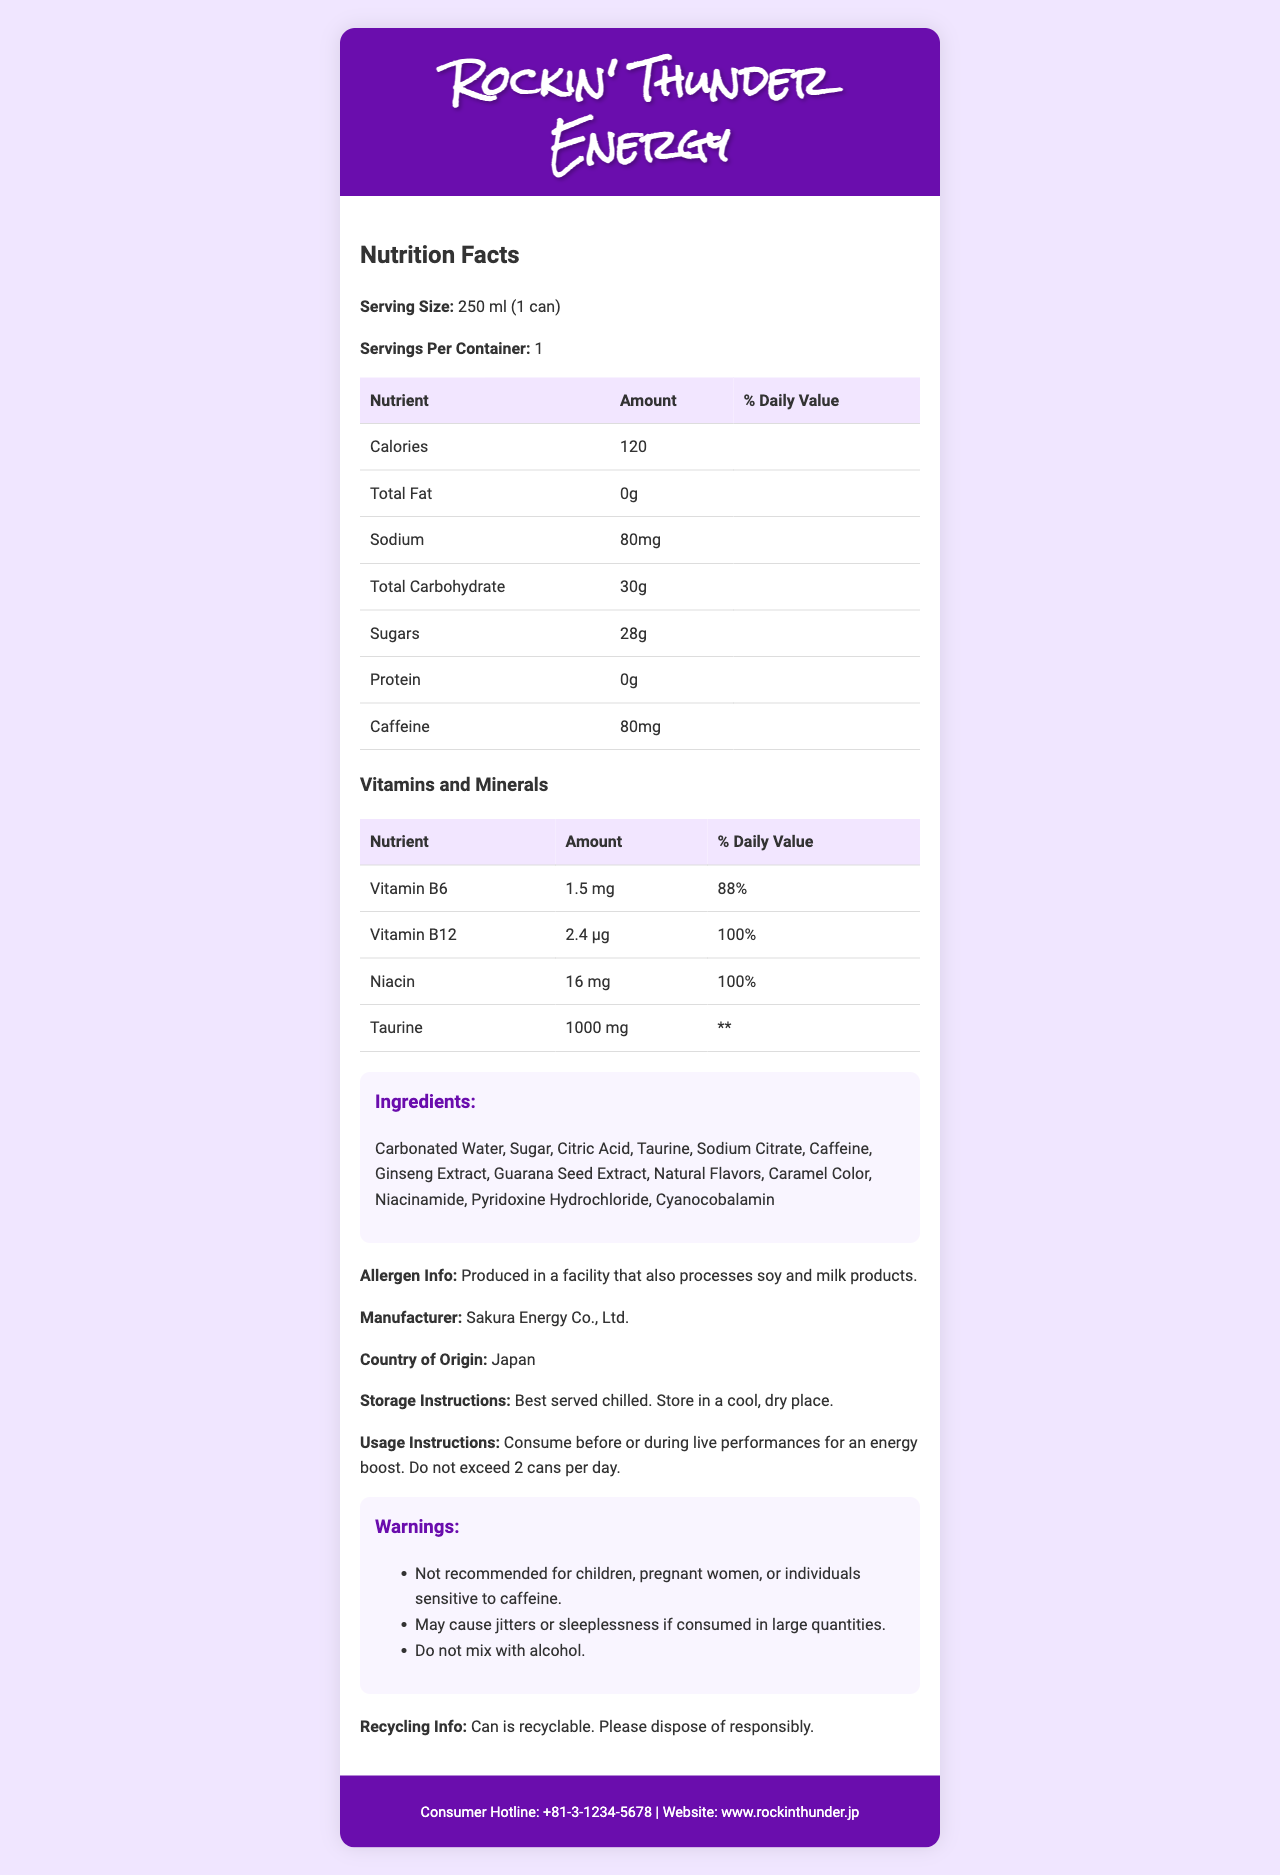How many calories are in one can of Rockin' Thunder Energy? The document states that one serving size, which is one can, contains 120 calories.
Answer: 120 What is the serving size of Rockin' Thunder Energy? The serving size information in the document specifies that one can is 250 ml.
Answer: 250 ml How much sodium is in one serving of Rockin' Thunder Energy? The document lists the sodium content as 80 mg per serving.
Answer: 80 mg How many grams of sugar are in one can? According to the nutrition facts, one serving, or one can, contains 28 grams of sugars.
Answer: 28 g What percentage of the daily value of Vitamin B12 does one can provide? The document indicates that one serving provides 100% of the daily value of Vitamin B12.
Answer: 100% Which of the following is not an ingredient in Rockin' Thunder Energy? A. Caffeine B. Ginseng Extract C. Aspartame D. Taurine The ingredients listed in the document do not include Aspartame.
Answer: C. Aspartame How many vitamins and minerals are explicitly listed in the nutrition facts? A. 2 B. 3 C. 4 D. 5 The document lists four vitamins and minerals: Vitamin B6, Vitamin B12, Niacin, and Taurine.
Answer: C. 4 Is Rockin' Thunder Energy recommended for children? The warnings section of the document advises that the product is not recommended for children.
Answer: No Summarize the key information provided in the Nutrition Facts Label for Rockin' Thunder Energy. The Nutrition Facts Label gives detailed information on the drink’s calorie count, nutrient content, vitamins, minerals, ingredients, usage instructions, and warnings.
Answer: Rockin' Thunder Energy provides 120 calories per 250 ml can, with 0g fat, 80mg sodium, 30g total carbohydrates (including 28g sugars), and 0g protein. It contains 80mg caffeine and significant amounts of Vitamin B6, Vitamin B12, Niacin, and Taurine. Key ingredients include sugar, taurine, caffeine, ginseng extract, and guarana seed extract. There are warnings about consumption limits and not mixing with alcohol. How much caffeine is in one can of Rockin' Thunder Energy? The document specifies that there is 80 mg of caffeine per can.
Answer: 80 mg What is the manufacturer's name for Rockin' Thunder Energy? The document states that the manufacturer is Sakura Energy Co., Ltd.
Answer: Sakura Energy Co., Ltd. Can the document determine how much Vitamin C is in Rockin' Thunder Energy? The document does not list Vitamin C among the vitamins and minerals.
Answer: Cannot be determined What are the storage instructions provided for Rockin' Thunder Energy? The document advises to serve the drink chilled and to store it in a cool, dry place.
Answer: Best served chilled. Store in a cool, dry place. How many grams of total carbohydrates are in one can? The document states that each serving contains 30 grams of total carbohydrates.
Answer: 30 g Is it safe to mix Rockin' Thunder Energy with alcoholic beverages according to the document? The warning section clearly states not to mix the energy drink with alcohol.
Answer: No What is the country of origin for Rockin' Thunder Energy? The document specifies that the drink is made in Japan.
Answer: Japan What are the potential side effects of consuming Rockin' Thunder Energy? The warnings section lists jitters and sleeplessness as potential side effects if consumed in large quantities.
Answer: May cause jitters or sleeplessness if consumed in large quantities. How many servings are in one container of Rockin' Thunder Energy? The document indicates that there is one serving per container.
Answer: 1 